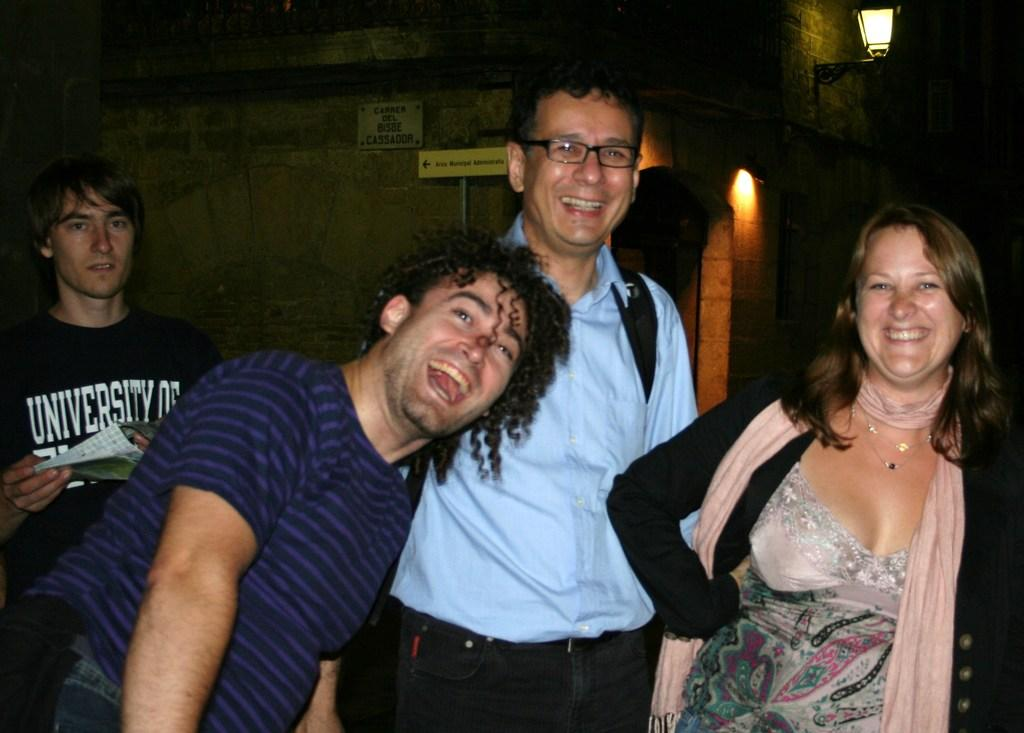What are the people in the image wearing? The persons in the image are wearing clothes. What can be seen in the top right corner of the image? There are lights in the top right of the image. What is located at the top of the image? There is a wall at the top of the image. What date is marked on the calendar in the image? There is no calendar present in the image. How many minutes does it take for the person to put on their cap in the image? There is no cap present in the image, and therefore no such action can be observed. 